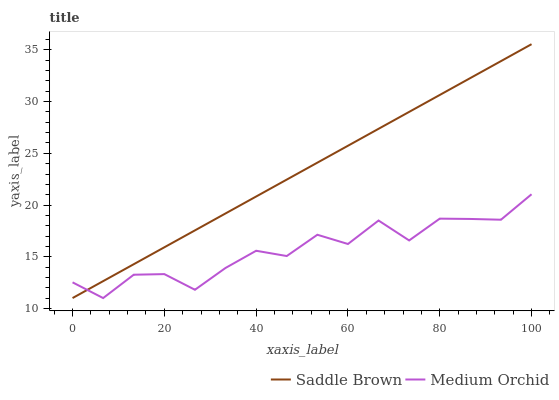Does Medium Orchid have the minimum area under the curve?
Answer yes or no. Yes. Does Saddle Brown have the maximum area under the curve?
Answer yes or no. Yes. Does Saddle Brown have the minimum area under the curve?
Answer yes or no. No. Is Saddle Brown the smoothest?
Answer yes or no. Yes. Is Medium Orchid the roughest?
Answer yes or no. Yes. Is Saddle Brown the roughest?
Answer yes or no. No. Does Medium Orchid have the lowest value?
Answer yes or no. Yes. Does Saddle Brown have the highest value?
Answer yes or no. Yes. Does Medium Orchid intersect Saddle Brown?
Answer yes or no. Yes. Is Medium Orchid less than Saddle Brown?
Answer yes or no. No. Is Medium Orchid greater than Saddle Brown?
Answer yes or no. No. 